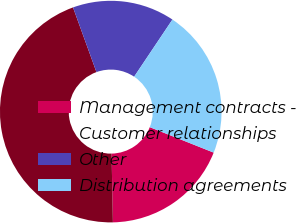<chart> <loc_0><loc_0><loc_500><loc_500><pie_chart><fcel>Management contracts -<fcel>Customer relationships<fcel>Other<fcel>Distribution agreements<nl><fcel>18.66%<fcel>44.78%<fcel>14.93%<fcel>21.64%<nl></chart> 